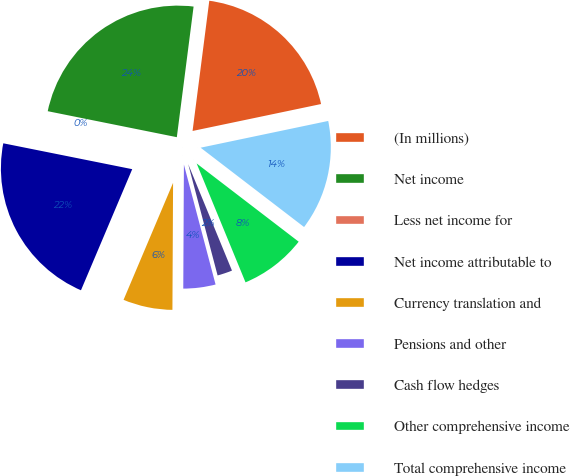<chart> <loc_0><loc_0><loc_500><loc_500><pie_chart><fcel>(In millions)<fcel>Net income<fcel>Less net income for<fcel>Net income attributable to<fcel>Currency translation and<fcel>Pensions and other<fcel>Cash flow hedges<fcel>Other comprehensive income<fcel>Total comprehensive income<nl><fcel>19.68%<fcel>23.87%<fcel>0.01%<fcel>21.78%<fcel>6.29%<fcel>4.19%<fcel>2.1%<fcel>8.38%<fcel>13.7%<nl></chart> 